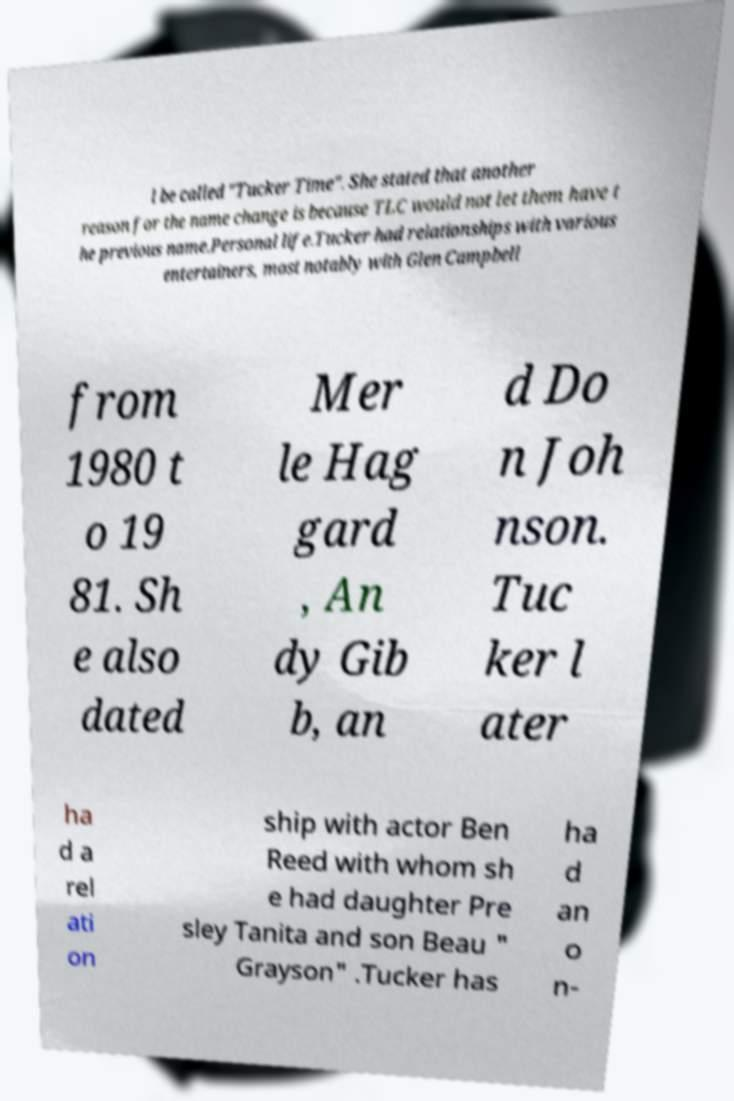There's text embedded in this image that I need extracted. Can you transcribe it verbatim? l be called "Tucker Time". She stated that another reason for the name change is because TLC would not let them have t he previous name.Personal life.Tucker had relationships with various entertainers, most notably with Glen Campbell from 1980 t o 19 81. Sh e also dated Mer le Hag gard , An dy Gib b, an d Do n Joh nson. Tuc ker l ater ha d a rel ati on ship with actor Ben Reed with whom sh e had daughter Pre sley Tanita and son Beau " Grayson" .Tucker has ha d an o n- 